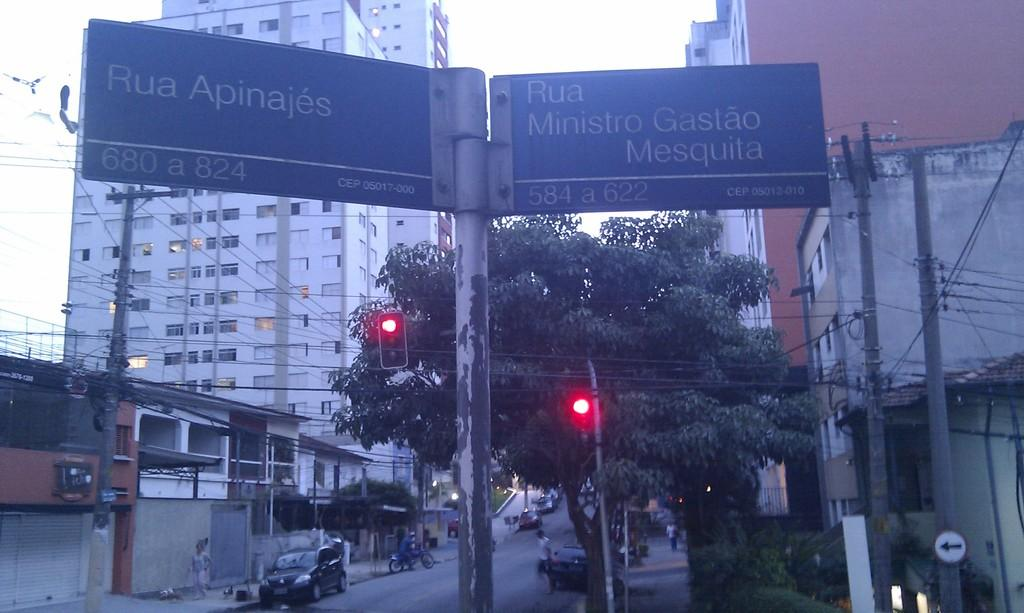<image>
Create a compact narrative representing the image presented. A sign for Rua Apinajes is next to a sign for Rua Ministro Gastao Mesquita. 